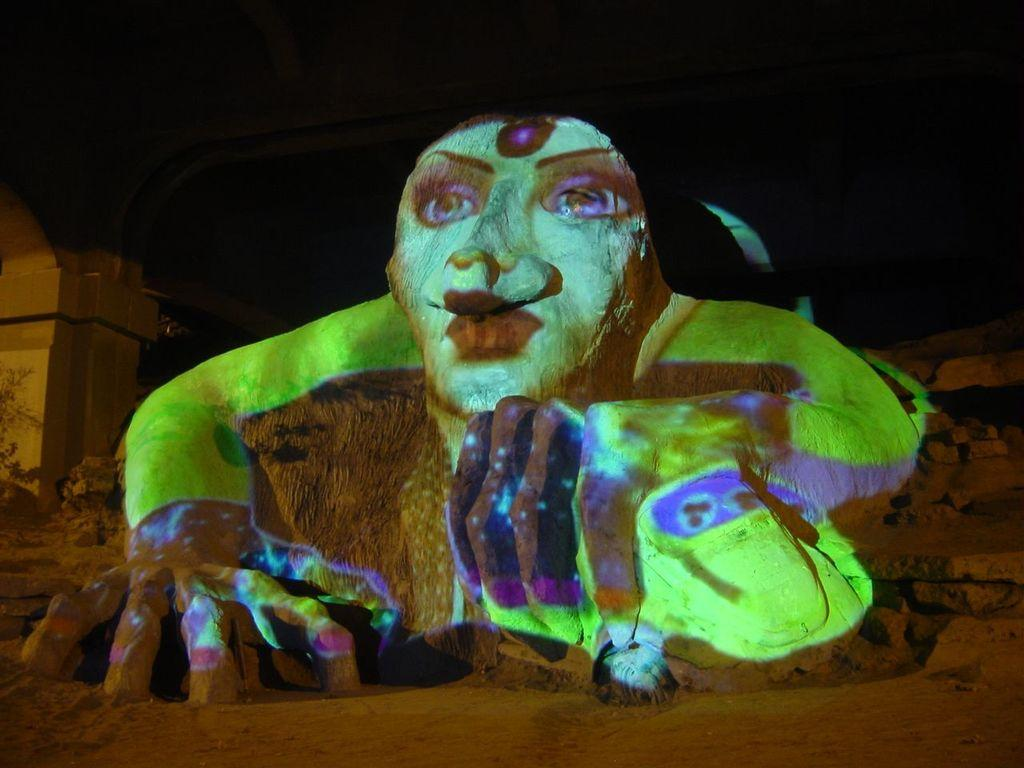What is the medium used for the artwork in the image? The image is a painting done on a rock. When was the image captured? The image was captured at night time. What type of competition is taking place in the image? There is no competition present in the image; it features a painting on a rock captured at night time. What type of weather condition is visible in the image? The image does not show any specific weather condition, as it is a painting on a rock captured at night time. 